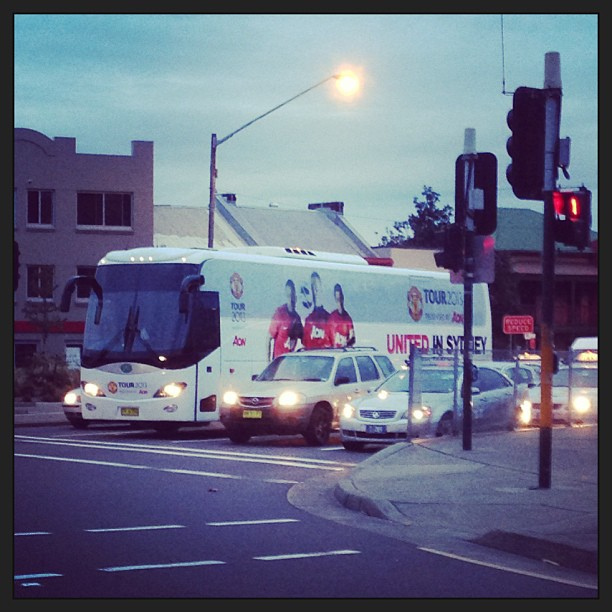Identify and read out the text in this image. UNITED IN SYDNEY TOUR TOUR 